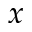<formula> <loc_0><loc_0><loc_500><loc_500>x</formula> 